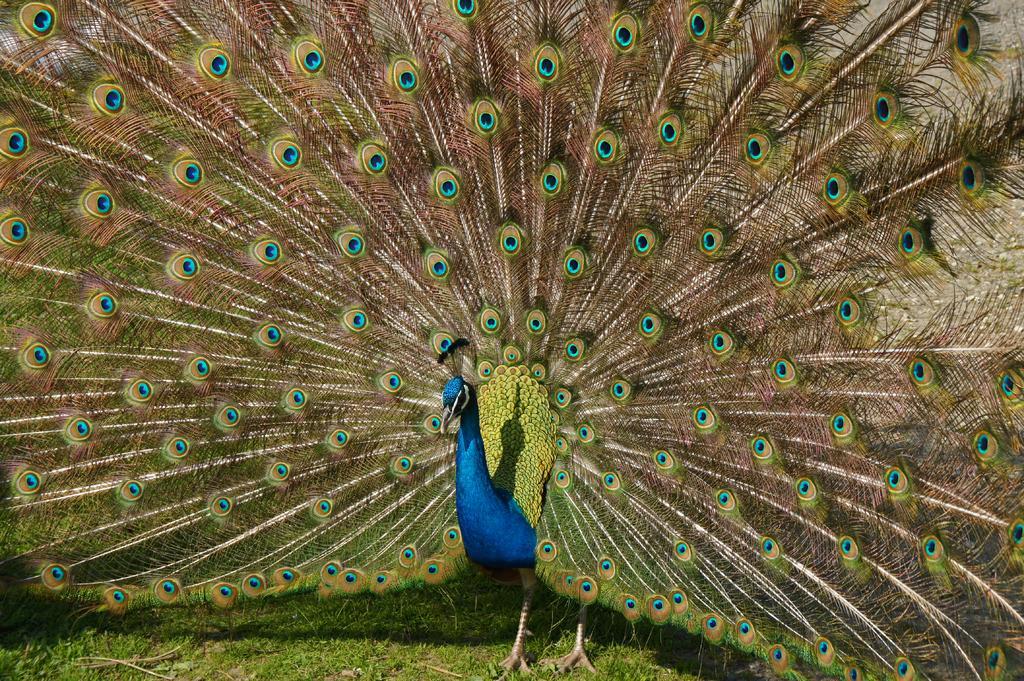How would you summarize this image in a sentence or two? In this image we can see a peacock on the grass. 